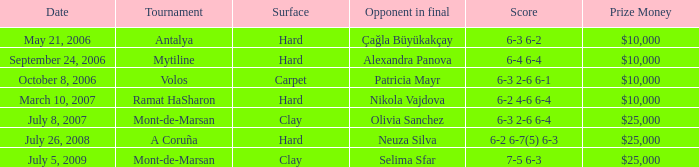What's the current standing in the hard court ramat hasharon event? 6-2 4-6 6-4. 